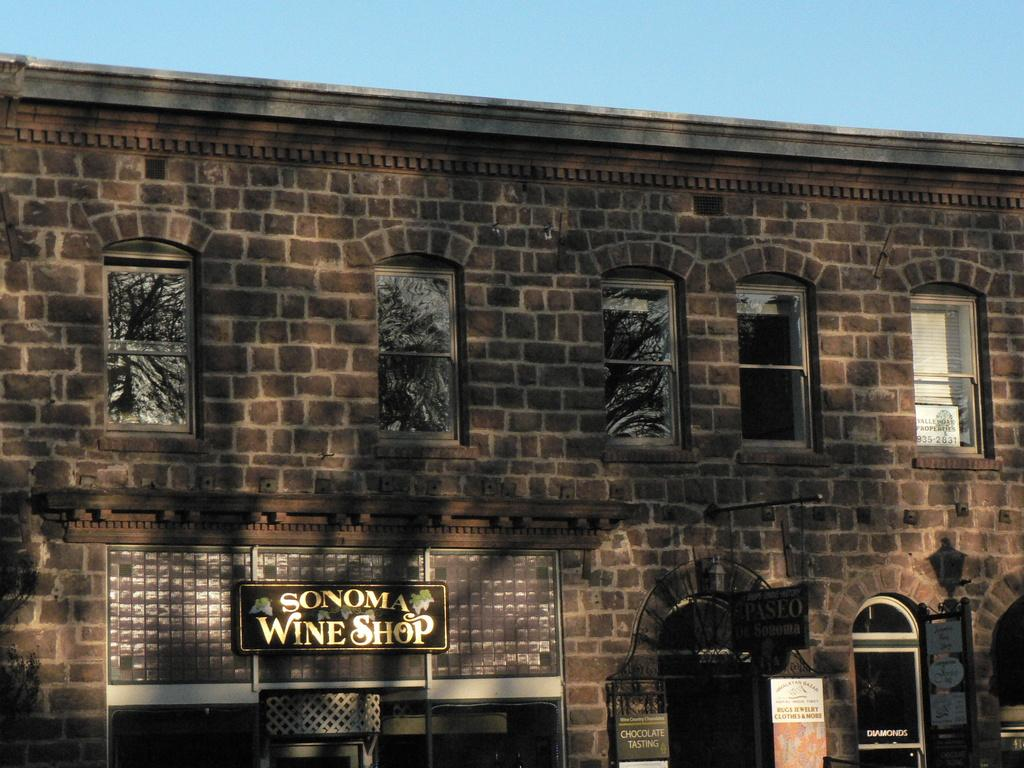Provide a one-sentence caption for the provided image. the exterior brick facade of Sonoma Wine Shop. 